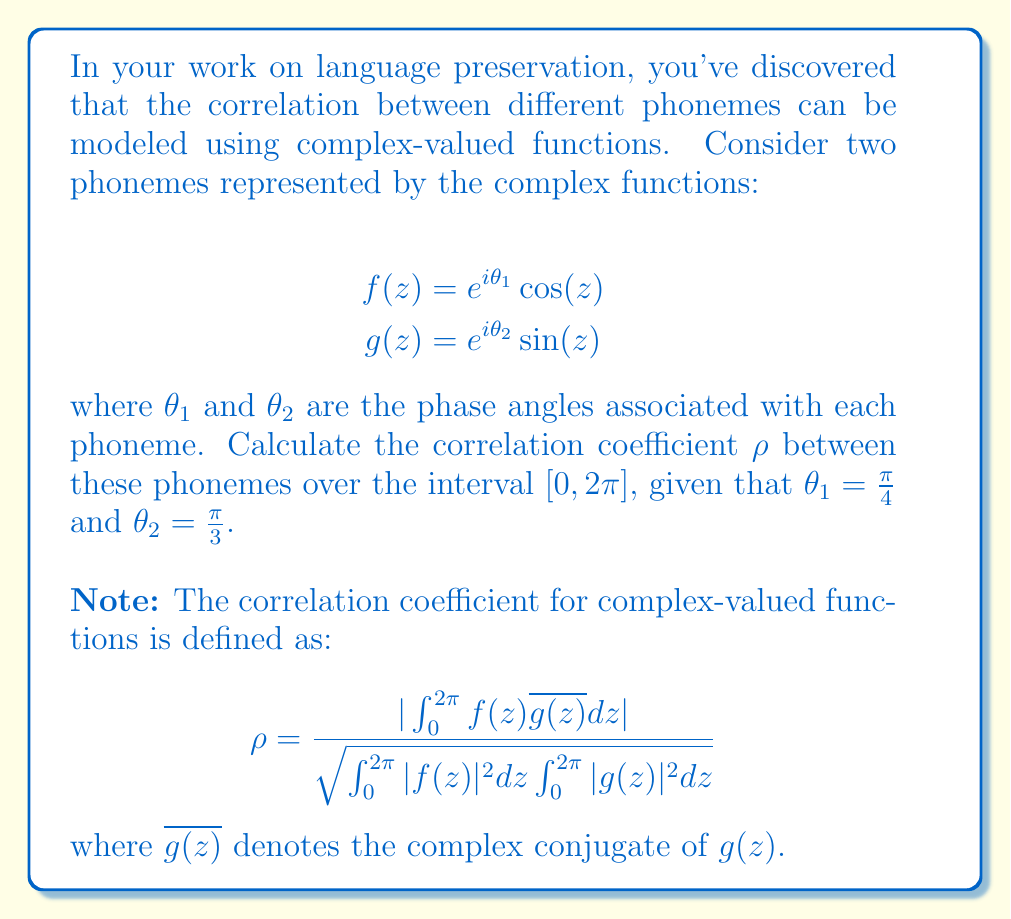Solve this math problem. Let's approach this step-by-step:

1) First, we need to calculate $f(z)\overline{g(z)}$:
   $$f(z)\overline{g(z)} = e^{i\theta_1} \cos(z) \cdot e^{-i\theta_2} \sin(z) = e^{i(\theta_1-\theta_2)} \cos(z)\sin(z)$$

2) Now, let's calculate the numerator:
   $$\int_0^{2\pi} f(z)\overline{g(z)}dz = e^{i(\theta_1-\theta_2)} \int_0^{2\pi} \cos(z)\sin(z)dz$$
   $$= e^{i(\theta_1-\theta_2)} \cdot \frac{1}{2} \int_0^{2\pi} \sin(2z)dz = 0$$

3) For the denominator, we need to calculate $\int_0^{2\pi} |f(z)|^2dz$ and $\int_0^{2\pi} |g(z)|^2dz$:
   $$\int_0^{2\pi} |f(z)|^2dz = \int_0^{2\pi} \cos^2(z)dz = \pi$$
   $$\int_0^{2\pi} |g(z)|^2dz = \int_0^{2\pi} \sin^2(z)dz = \pi$$

4) Putting it all together:
   $$\rho = \frac{|0|}{\sqrt{\pi \cdot \pi}} = 0$$

5) The result is independent of $\theta_1$ and $\theta_2$, so we didn't need to use their specific values.
Answer: $\rho = 0$ 